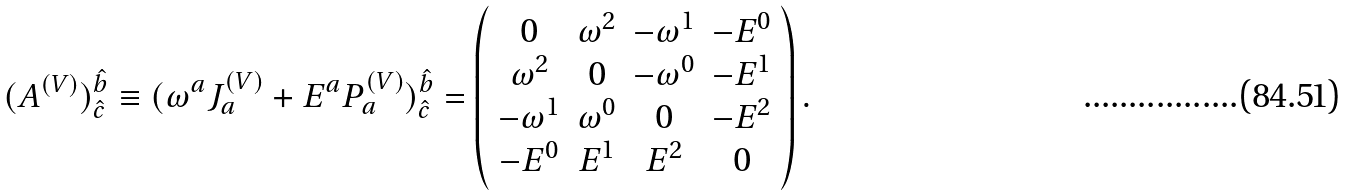<formula> <loc_0><loc_0><loc_500><loc_500>( A ^ { ( V ) } ) _ { \hat { c } } ^ { \hat { b } } \equiv ( \omega ^ { a } J _ { a } ^ { ( V ) } + E ^ { a } P _ { a } ^ { ( V ) } ) _ { \hat { c } } ^ { \hat { b } } = \left ( \begin{array} { c c c c } { 0 } & { { \omega ^ { 2 } } } & { { - \omega ^ { 1 } } } & { { - E ^ { 0 } } } \\ { { \omega ^ { 2 } } } & { 0 } & { { - \omega ^ { 0 } } } & { { - E ^ { 1 } } } \\ { { - \omega ^ { 1 } } } & { { \omega ^ { 0 } } } & { 0 } & { { - E ^ { 2 } } } \\ { { - E ^ { 0 } } } & { { E ^ { 1 } } } & { { E ^ { 2 } } } & { 0 } \end{array} \right ) .</formula> 